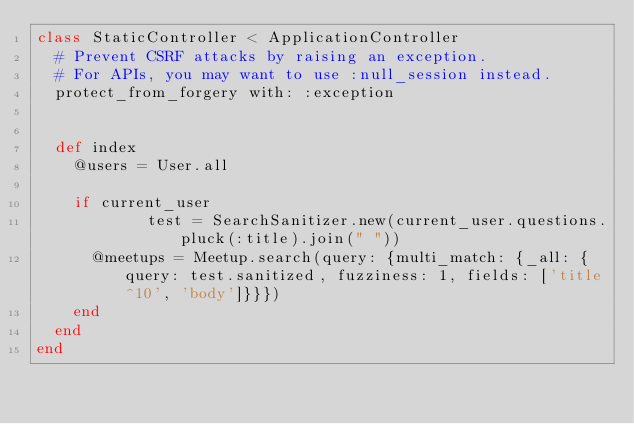<code> <loc_0><loc_0><loc_500><loc_500><_Ruby_>class StaticController < ApplicationController
  # Prevent CSRF attacks by raising an exception.
  # For APIs, you may want to use :null_session instead.
  protect_from_forgery with: :exception


	def index
    @users = User.all

		if current_user
            test = SearchSanitizer.new(current_user.questions.pluck(:title).join(" "))
			@meetups = Meetup.search(query: {multi_match: {_all: {query: test.sanitized, fuzziness: 1, fields: ['title^10', 'body']}}})
		end
	end
end
















</code> 